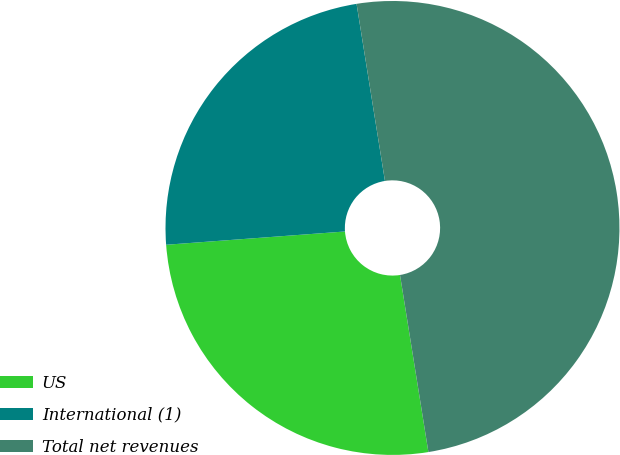<chart> <loc_0><loc_0><loc_500><loc_500><pie_chart><fcel>US<fcel>International (1)<fcel>Total net revenues<nl><fcel>26.35%<fcel>23.65%<fcel>50.0%<nl></chart> 